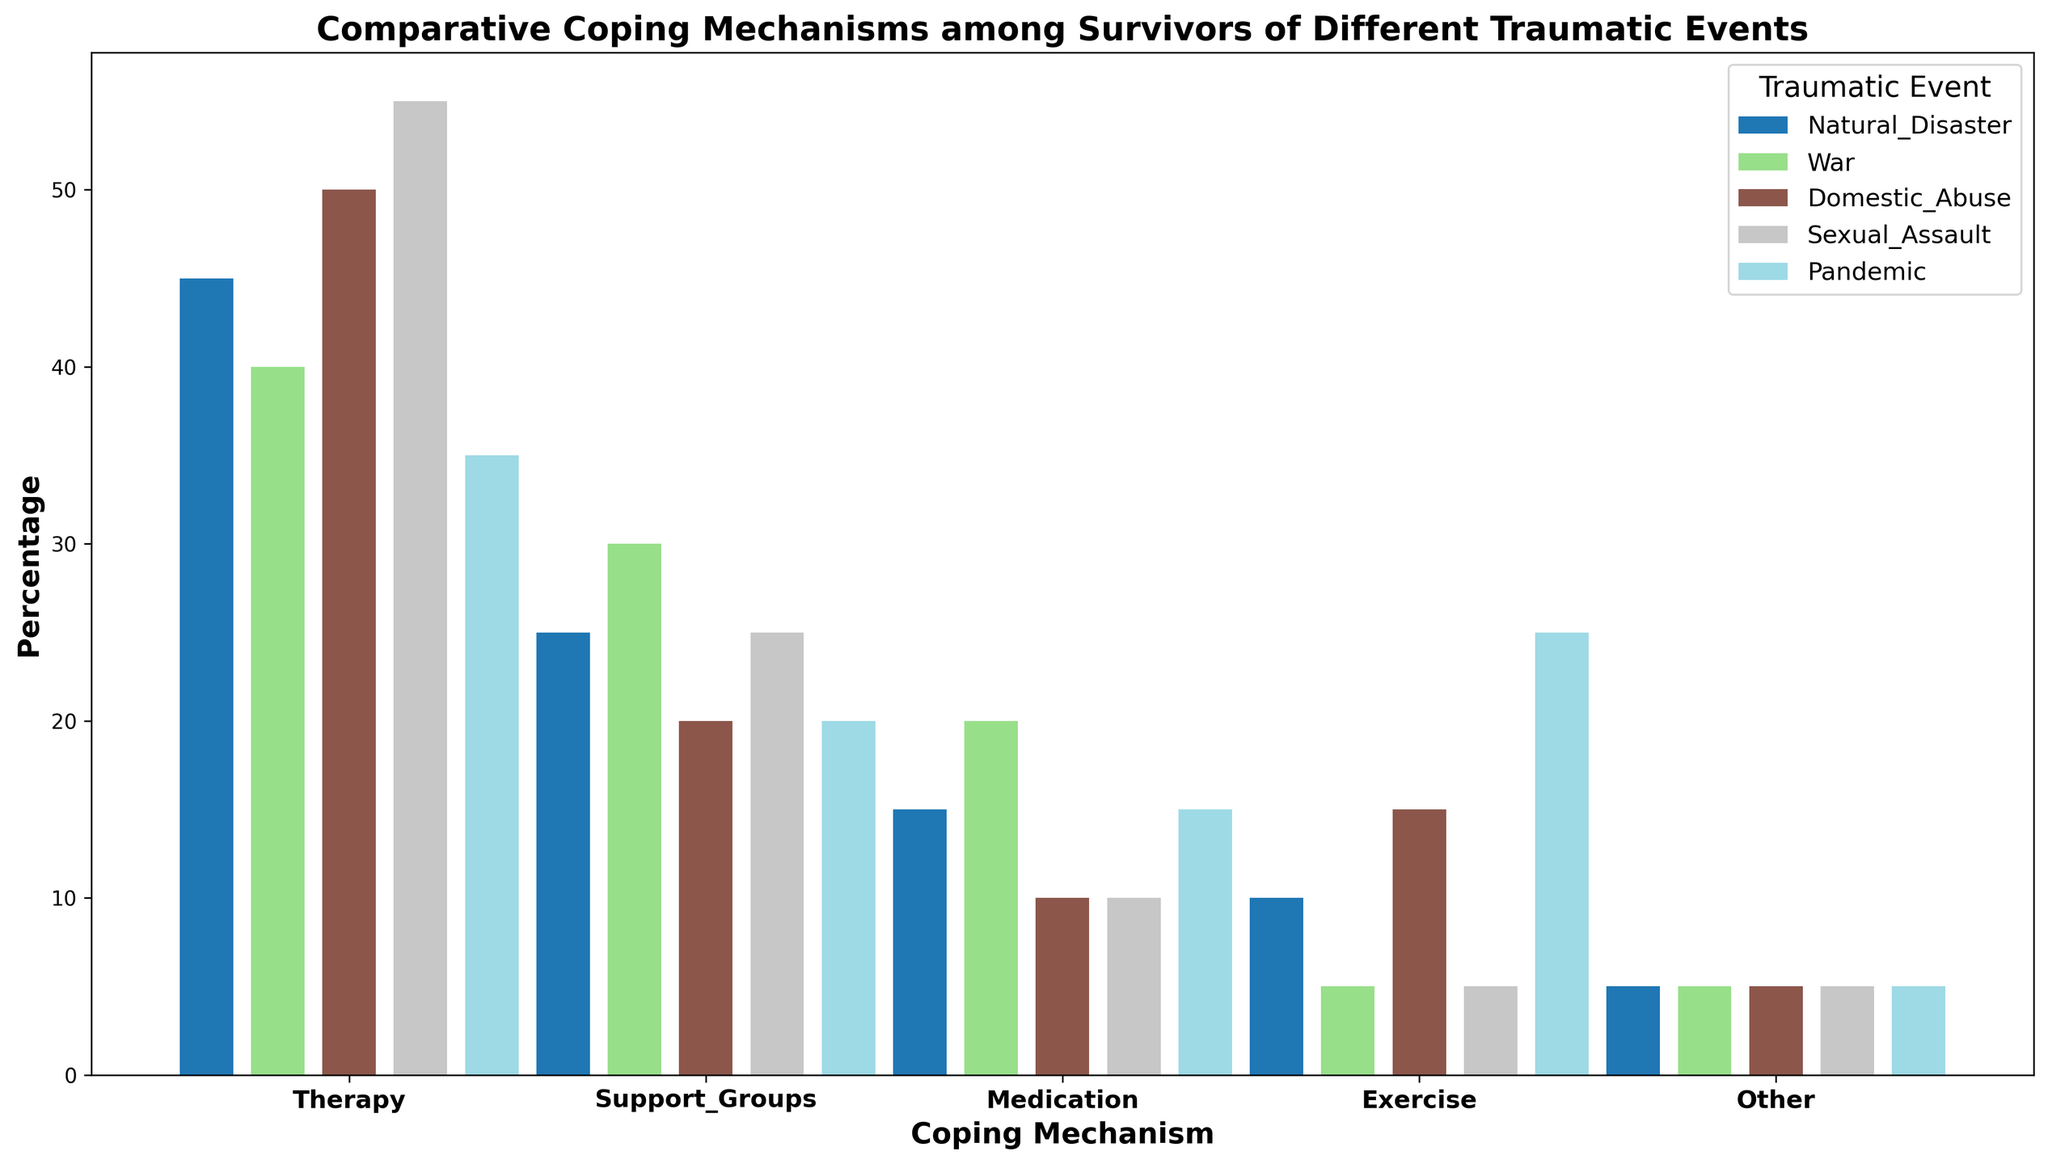What coping mechanism is most utilized by survivors of sexual assault? The highest bar for the "Sexual Assault" category represents the "Therapy" coping mechanism.
Answer: Therapy Which traumatic event group has the lowest percentage utilization of support groups as a coping mechanism? Among the five traumatic events, the group with the smallest bar labeled "Support Groups" belongs to "Domestic Abuse" with 20%.
Answer: Domestic Abuse Compare the utilization of exercise as a coping mechanism between survivors of natural disasters and pandemics. The bar representing "Exercise" in the "Pandemic" group is taller than that in the "Natural Disaster" group. Exercise utilization is 25% for pandemics and 10% for natural disasters.
Answer: Pandemics utilize exercise more What is the total percentage of survivors from war using either medication or support groups? For the "War" group, the percentages for "Medication" and "Support Groups" are 20% and 30%, respectively. Adding these gives 20% + 30% = 50%.
Answer: 50% Which coping mechanism has the highest combined percentage across all traumatic event groups? Summing all the percentages for each coping mechanism across all groups:
Therapy: 45 + 40 + 50 + 55 + 35 = 225
Support Groups: 25 + 30 + 20 + 25 + 20 = 120
Medication: 15 + 20 + 10 + 10 + 15 = 70
Exercise: 10 + 5 + 15 + 5 + 25 = 60
Other: 5 + 5 + 5 + 5 + 5 = 25. 
Therapy has the highest combined percentage of 225%.
Answer: Therapy Which coping mechanism shows the least variation in usage across different traumatic events? By observing the height of the bars, "Other" has the least variation with a consistent usage of 5% in all groups.
Answer: Other In which traumatic event is the percentage of therapy as a coping mechanism the highest? Among all the traumatic events, the "Sexual Assault" group has the tallest bar for "Therapy" at 55%.
Answer: Sexual Assault How does the utilization of medication as a coping mechanism compare between domestic abuse and war survivors? For "Domestic Abuse," the medication utilization is 10%, and for "War," it is 20%. "War" has a higher utilization of medication.
Answer: War has higher medication utilization 